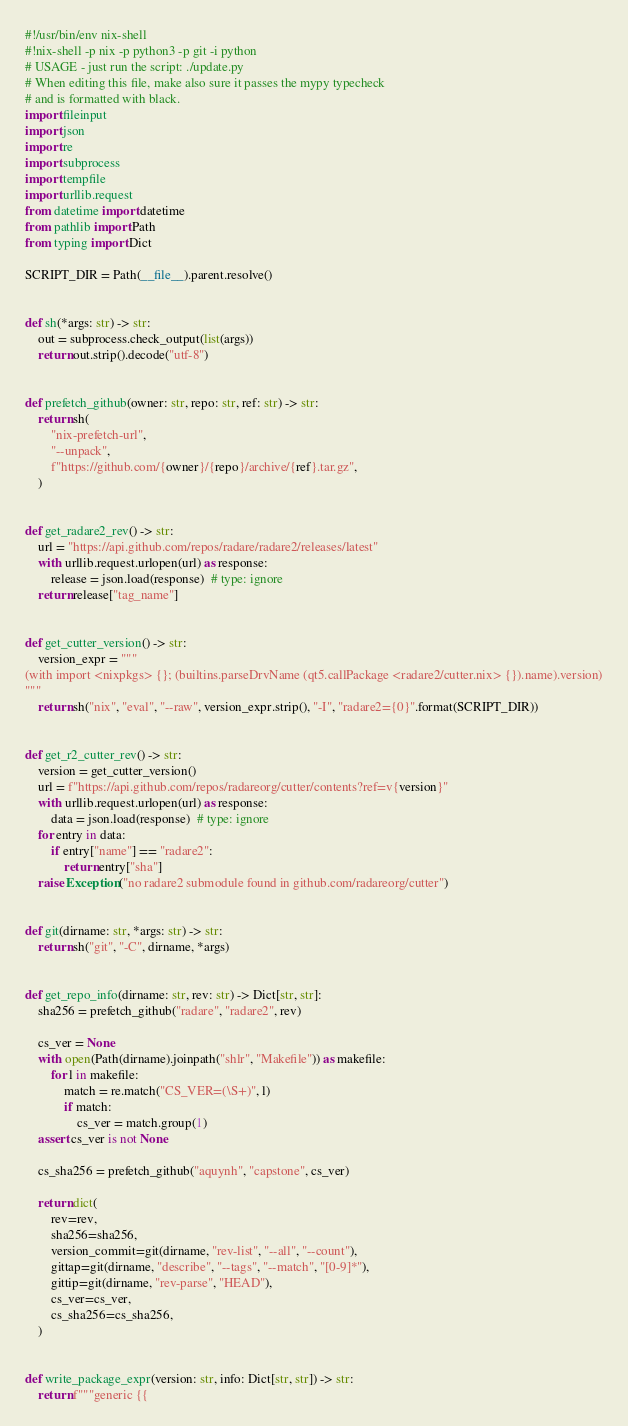<code> <loc_0><loc_0><loc_500><loc_500><_Python_>#!/usr/bin/env nix-shell
#!nix-shell -p nix -p python3 -p git -i python
# USAGE - just run the script: ./update.py
# When editing this file, make also sure it passes the mypy typecheck
# and is formatted with black.
import fileinput
import json
import re
import subprocess
import tempfile
import urllib.request
from datetime import datetime
from pathlib import Path
from typing import Dict

SCRIPT_DIR = Path(__file__).parent.resolve()


def sh(*args: str) -> str:
    out = subprocess.check_output(list(args))
    return out.strip().decode("utf-8")


def prefetch_github(owner: str, repo: str, ref: str) -> str:
    return sh(
        "nix-prefetch-url",
        "--unpack",
        f"https://github.com/{owner}/{repo}/archive/{ref}.tar.gz",
    )


def get_radare2_rev() -> str:
    url = "https://api.github.com/repos/radare/radare2/releases/latest"
    with urllib.request.urlopen(url) as response:
        release = json.load(response)  # type: ignore
    return release["tag_name"]


def get_cutter_version() -> str:
    version_expr = """
(with import <nixpkgs> {}; (builtins.parseDrvName (qt5.callPackage <radare2/cutter.nix> {}).name).version)
"""
    return sh("nix", "eval", "--raw", version_expr.strip(), "-I", "radare2={0}".format(SCRIPT_DIR))


def get_r2_cutter_rev() -> str:
    version = get_cutter_version()
    url = f"https://api.github.com/repos/radareorg/cutter/contents?ref=v{version}"
    with urllib.request.urlopen(url) as response:
        data = json.load(response)  # type: ignore
    for entry in data:
        if entry["name"] == "radare2":
            return entry["sha"]
    raise Exception("no radare2 submodule found in github.com/radareorg/cutter")


def git(dirname: str, *args: str) -> str:
    return sh("git", "-C", dirname, *args)


def get_repo_info(dirname: str, rev: str) -> Dict[str, str]:
    sha256 = prefetch_github("radare", "radare2", rev)

    cs_ver = None
    with open(Path(dirname).joinpath("shlr", "Makefile")) as makefile:
        for l in makefile:
            match = re.match("CS_VER=(\S+)", l)
            if match:
                cs_ver = match.group(1)
    assert cs_ver is not None

    cs_sha256 = prefetch_github("aquynh", "capstone", cs_ver)

    return dict(
        rev=rev,
        sha256=sha256,
        version_commit=git(dirname, "rev-list", "--all", "--count"),
        gittap=git(dirname, "describe", "--tags", "--match", "[0-9]*"),
        gittip=git(dirname, "rev-parse", "HEAD"),
        cs_ver=cs_ver,
        cs_sha256=cs_sha256,
    )


def write_package_expr(version: str, info: Dict[str, str]) -> str:
    return f"""generic {{</code> 